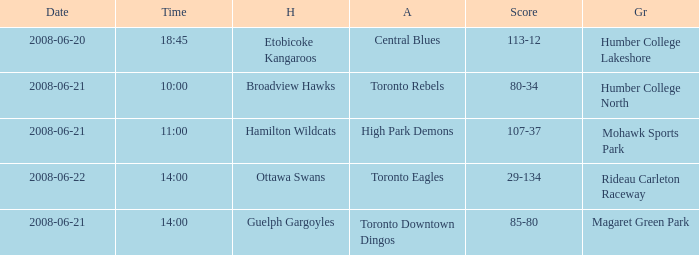What is the Time with a Ground that is humber college north? 10:00. 